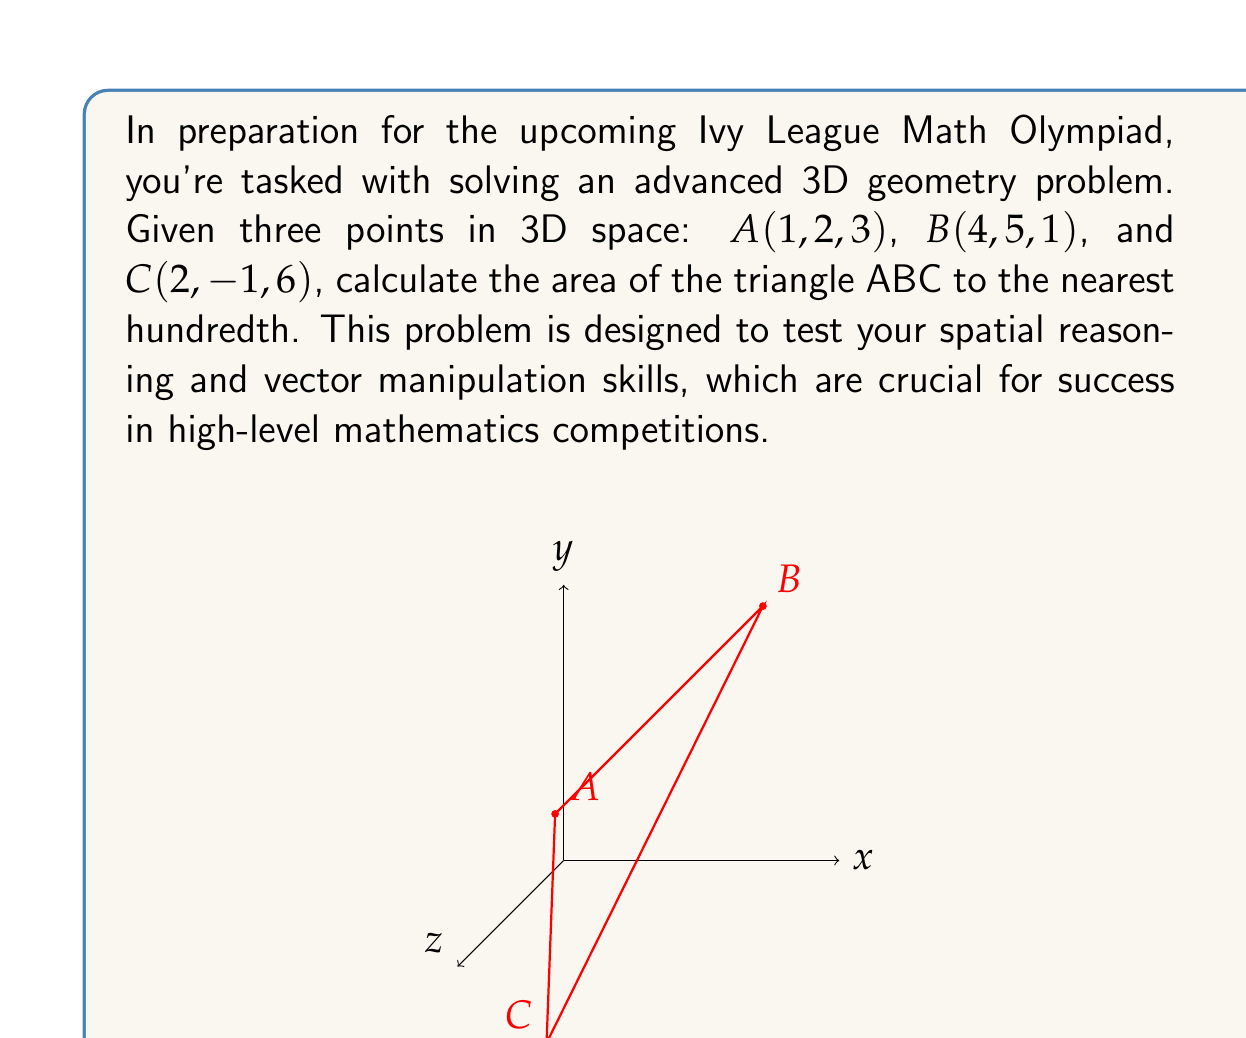Could you help me with this problem? Let's approach this step-by-step:

1) To find the area of a triangle in 3D space, we can use the formula:

   Area = $\frac{1}{2}|\vec{v} \times \vec{w}|$

   where $\vec{v}$ and $\vec{w}$ are two vectors formed by the sides of the triangle.

2) Let's define our vectors:
   $\vec{v} = \vec{AB} = B - A = (4-1, 5-2, 1-3) = (3, 3, -2)$
   $\vec{w} = \vec{AC} = C - A = (2-1, -1-2, 6-3) = (1, -3, 3)$

3) Now we need to calculate the cross product $\vec{v} \times \vec{w}$:

   $\vec{v} \times \vec{w} = \begin{vmatrix} 
   i & j & k \\
   3 & 3 & -2 \\
   1 & -3 & 3
   \end{vmatrix}$

   $= (3(3) - (-2)(-3))i - (3(3) - (-2)(1))j + (3(-3) - 3(1))k$
   $= (9 - 6)i - (9 - (-2))j + (-9 - 3)k$
   $= 3i - 11j - 12k$

4) The magnitude of this cross product is:

   $|\vec{v} \times \vec{w}| = \sqrt{3^2 + (-11)^2 + (-12)^2}$
                              $= \sqrt{9 + 121 + 144}$
                              $= \sqrt{274}$

5) Therefore, the area of the triangle is:

   Area = $\frac{1}{2}\sqrt{274}$

6) Using a calculator and rounding to the nearest hundredth:

   Area ≈ 8.28
Answer: 8.28 square units 